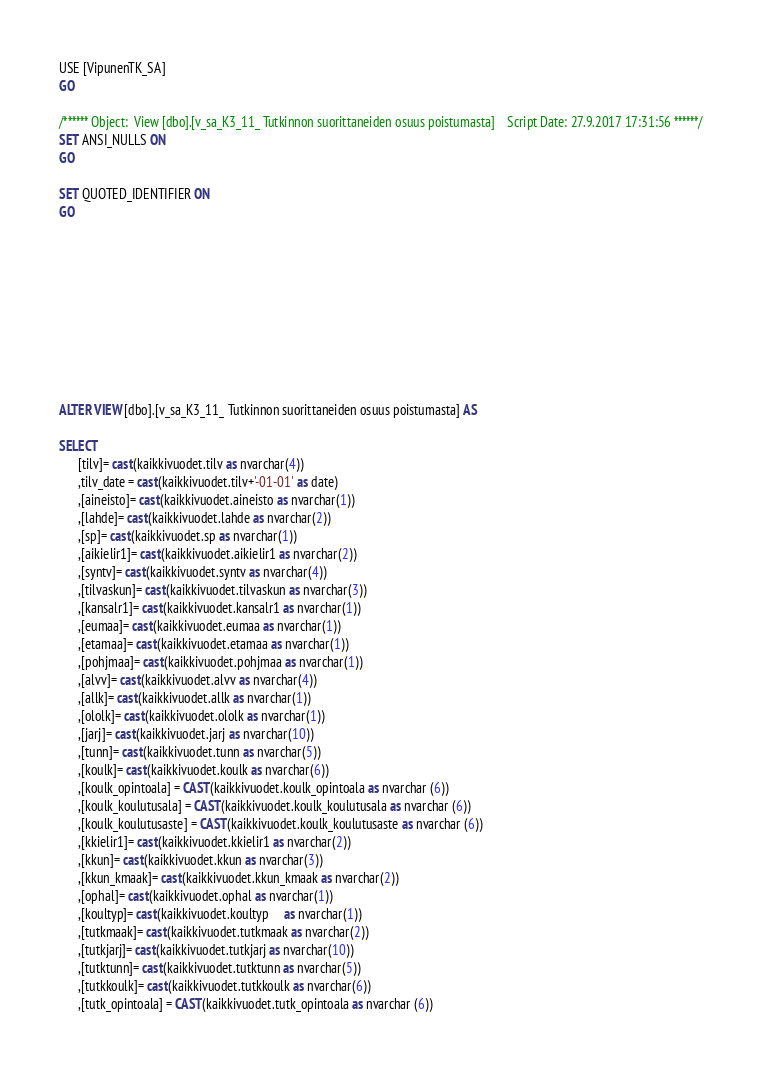Convert code to text. <code><loc_0><loc_0><loc_500><loc_500><_SQL_>USE [VipunenTK_SA]
GO

/****** Object:  View [dbo].[v_sa_K3_11_ Tutkinnon suorittaneiden osuus poistumasta]    Script Date: 27.9.2017 17:31:56 ******/
SET ANSI_NULLS ON
GO

SET QUOTED_IDENTIFIER ON
GO










ALTER VIEW [dbo].[v_sa_K3_11_ Tutkinnon suorittaneiden osuus poistumasta] AS

SELECT
      [tilv]= cast(kaikkivuodet.tilv as nvarchar(4))
	  ,tilv_date = cast(kaikkivuodet.tilv+'-01-01' as date)
      ,[aineisto]= cast(kaikkivuodet.aineisto as nvarchar(1))
      ,[lahde]= cast(kaikkivuodet.lahde as nvarchar(2))
      ,[sp]= cast(kaikkivuodet.sp as nvarchar(1))
      ,[aikielir1]= cast(kaikkivuodet.aikielir1 as nvarchar(2))
      ,[syntv]= cast(kaikkivuodet.syntv as nvarchar(4))
      ,[tilvaskun]= cast(kaikkivuodet.tilvaskun as nvarchar(3))
      ,[kansalr1]= cast(kaikkivuodet.kansalr1 as nvarchar(1))
      ,[eumaa]= cast(kaikkivuodet.eumaa as nvarchar(1))
      ,[etamaa]= cast(kaikkivuodet.etamaa as nvarchar(1))
      ,[pohjmaa]= cast(kaikkivuodet.pohjmaa as nvarchar(1))
      ,[alvv]= cast(kaikkivuodet.alvv as nvarchar(4))
      ,[allk]= cast(kaikkivuodet.allk as nvarchar(1))
      ,[ololk]= cast(kaikkivuodet.ololk as nvarchar(1))
      ,[jarj]= cast(kaikkivuodet.jarj as nvarchar(10))
      ,[tunn]= cast(kaikkivuodet.tunn as nvarchar(5))
      ,[koulk]= cast(kaikkivuodet.koulk as nvarchar(6))
	  ,[koulk_opintoala] = CAST(kaikkivuodet.koulk_opintoala as nvarchar (6))
	  ,[koulk_koulutusala] = CAST(kaikkivuodet.koulk_koulutusala as nvarchar (6))
	  ,[koulk_koulutusaste] = CAST(kaikkivuodet.koulk_koulutusaste as nvarchar (6))
      ,[kkielir1]= cast(kaikkivuodet.kkielir1 as nvarchar(2))
      ,[kkun]= cast(kaikkivuodet.kkun as nvarchar(3))
	  ,[kkun_kmaak]= cast(kaikkivuodet.kkun_kmaak as nvarchar(2))
	  ,[ophal]= cast(kaikkivuodet.ophal as nvarchar(1))
      ,[koultyp]= cast(kaikkivuodet.koultyp	 as nvarchar(1))
      ,[tutkmaak]= cast(kaikkivuodet.tutkmaak as nvarchar(2))
      ,[tutkjarj]= cast(kaikkivuodet.tutkjarj as nvarchar(10))
      ,[tutktunn]= cast(kaikkivuodet.tutktunn as nvarchar(5))
      ,[tutkkoulk]= cast(kaikkivuodet.tutkkoulk as nvarchar(6))
	  ,[tutk_opintoala] = CAST(kaikkivuodet.tutk_opintoala as nvarchar (6))</code> 